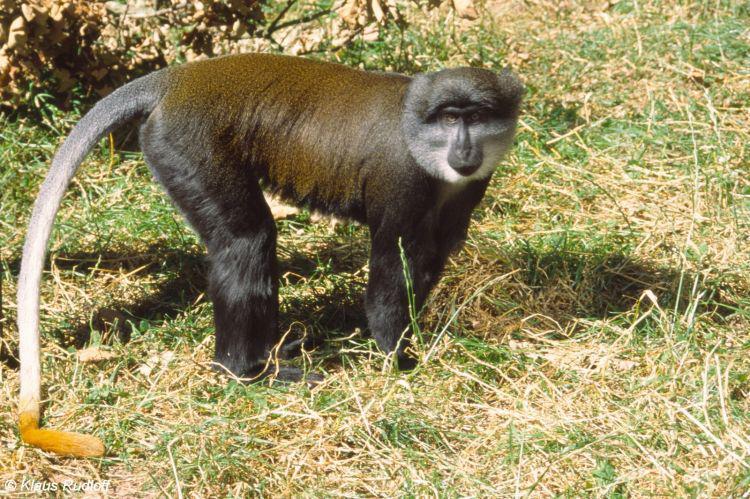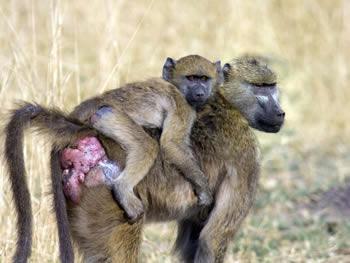The first image is the image on the left, the second image is the image on the right. Examine the images to the left and right. Is the description "Each image contains a single baboon, and all baboons are in standing positions." accurate? Answer yes or no. No. The first image is the image on the left, the second image is the image on the right. Considering the images on both sides, is "There is at least one male sacred baboon." valid? Answer yes or no. No. 